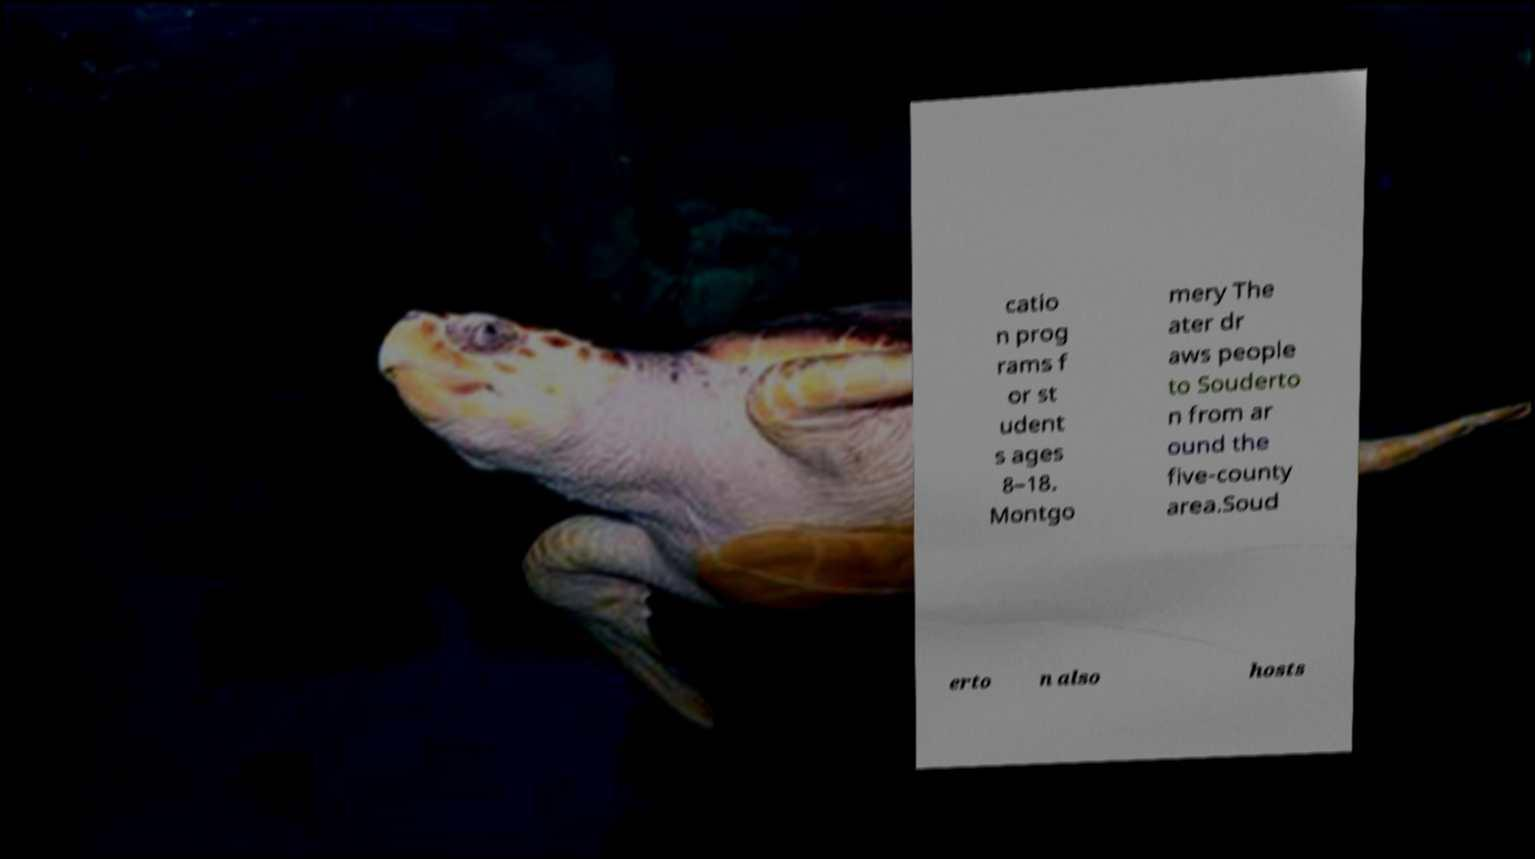There's text embedded in this image that I need extracted. Can you transcribe it verbatim? catio n prog rams f or st udent s ages 8–18. Montgo mery The ater dr aws people to Souderto n from ar ound the five-county area.Soud erto n also hosts 